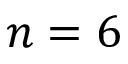Convert formula to latex. <formula><loc_0><loc_0><loc_500><loc_500>n = 6</formula> 